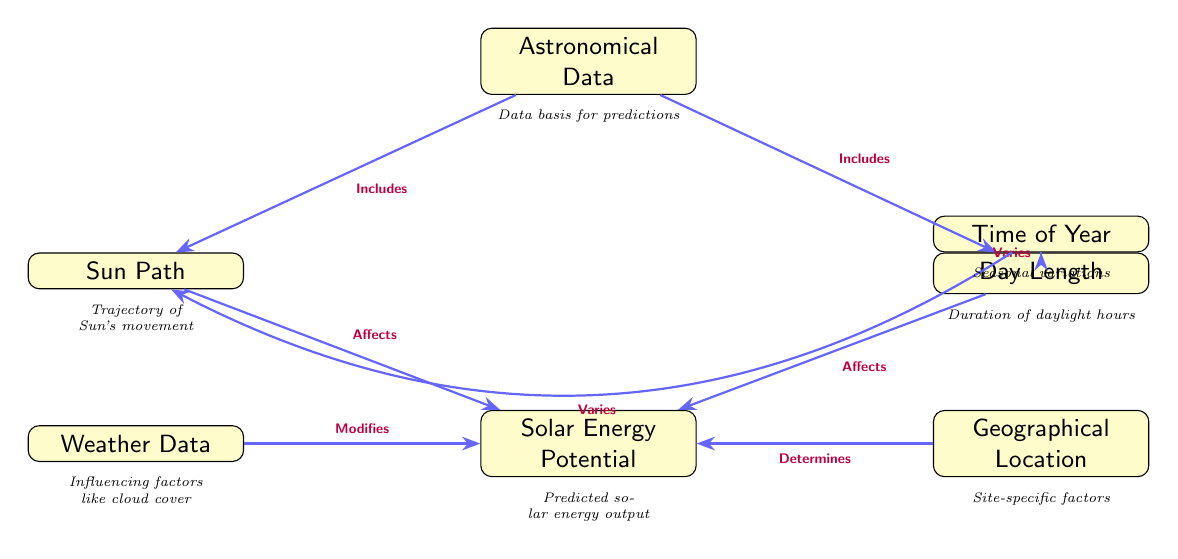What is included in the Astronomical Data node? The Astronomical Data node references the foundational data for the solar energy predictions. According to the diagram, this node includes both the Sun Path and Day Length nodes, as indicated by the arrows pointing from AD to SP and DL.
Answer: Sun Path and Day Length How many nodes are present in the diagram? Counting all distinct boxes, there are a total of seven nodes in the diagram: Astronomical Data, Sun Path, Day Length, Solar Energy Potential, Weather Data, Geographical Location, and Time of Year.
Answer: Seven What does the Geographical Location node determine? The Geographical Location node has an arrow pointing to the Solar Energy Potential node, labeled "Determines." This implies that the geographical factors at a specific site impact the predicted solar energy output.
Answer: Solar Energy Potential What affects the Solar Energy Potential based on this diagram? The diagram indicates that Solar Energy Potential is affected by both the Sun Path and Day Length. This is confirmed by the arrows connecting SP and DL to SEP, labeled "Affects."
Answer: Sun Path and Day Length How does the Time of Year affect the Day Length? There is an arrow from the Time of Year node to the Day Length node, labeled "Varies," showing that seasonal changes throughout the year impact the length of daylight hours.
Answer: Varies What kind of data does the Weather Data node modify? The Weather Data node is connected to the Solar Energy Potential node by an arrow labeled "Modifies," suggesting that weather conditions, such as cloud cover, can impact the predictions of solar energy output.
Answer: Solar Energy Potential Which node affects the Solar Energy Potential more significantly? The diagram shows contributions from multiple nodes—both Sun Path and Day Length affect Solar Energy Potential equally in terms of direct influence, as both feed into the SEP node. Therefore, neither has a greater impact according to the provided connections.
Answer: Equally What relationship does the Time of Year have with the Sun Path? The diagram depicts that the Time of Year varies in relation to the Sun Path, indicated by a bend arrow labeled "Varies" from TOY to SP. This shows that seasonal changes influence the trajectory of the Sun.
Answer: Varies What is the primary output of the Solar Energy Potential node? The output of the Solar Energy Potential node, as denoted by its labeling in the diagram, is the predicted solar energy output based on various factors included in the diagram.
Answer: Predicted solar energy output 